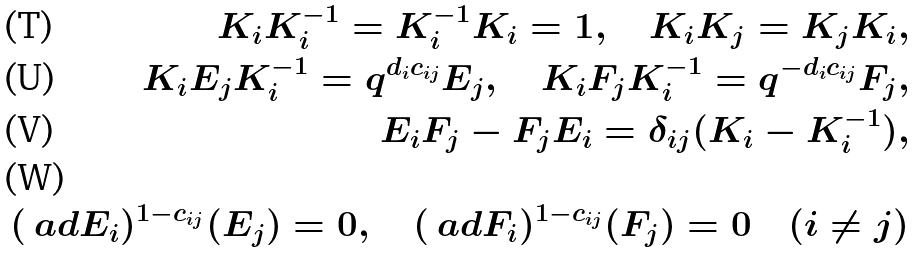<formula> <loc_0><loc_0><loc_500><loc_500>K _ { i } K _ { i } ^ { - 1 } = K _ { i } ^ { - 1 } K _ { i } = 1 , \quad K _ { i } K _ { j } = K _ { j } K _ { i } , \\ K _ { i } E _ { j } K _ { i } ^ { - 1 } = q ^ { d _ { i } c _ { i j } } E _ { j } , \quad K _ { i } F _ { j } K _ { i } ^ { - 1 } = q ^ { - d _ { i } c _ { i j } } F _ { j } , \\ E _ { i } F _ { j } - F _ { j } E _ { i } = \delta _ { i j } ( K _ { i } - K _ { i } ^ { - 1 } ) , \\ ( \ a d E _ { i } ) ^ { 1 - c _ { i j } } ( E _ { j } ) = 0 , \quad ( \ a d F _ { i } ) ^ { 1 - c _ { i j } } ( F _ { j } ) = 0 \quad ( i \not = j )</formula> 